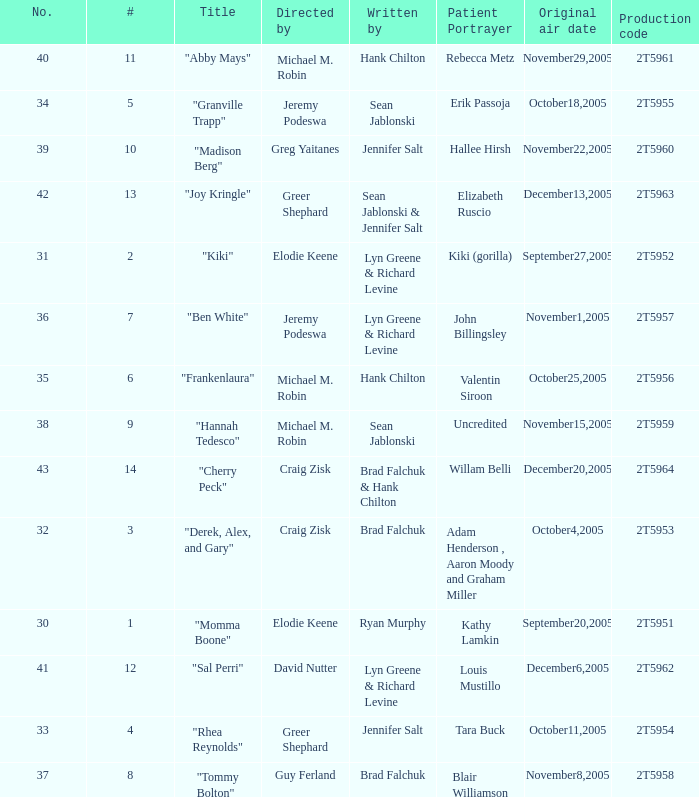Who were the writers for the episode titled "Ben White"? Lyn Greene & Richard Levine. 